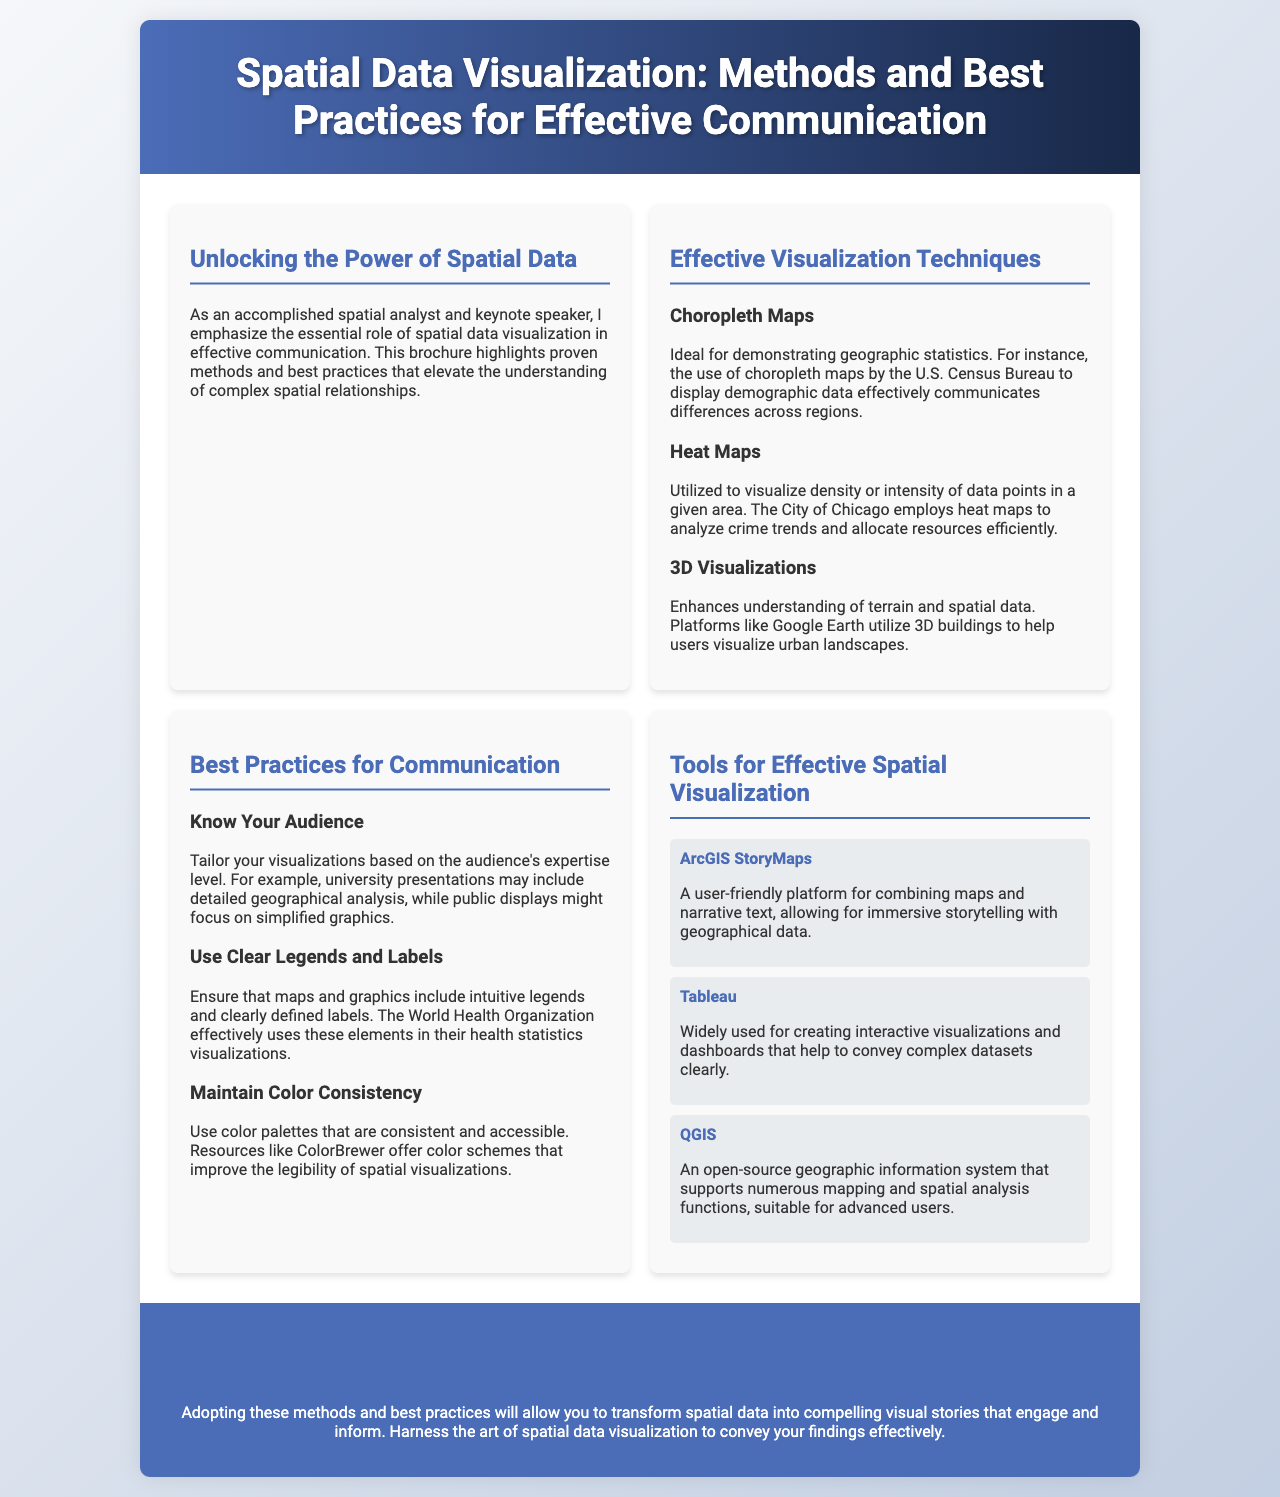what is the title of the brochure? The title of the brochure is prominently displayed in the header section.
Answer: Spatial Data Visualization: Methods and Best Practices for Effective Communication who is the intended audience for the visualization techniques? The document mentions tailoring visualizations based on the audience's expertise level, indicating different target groups.
Answer: Audience's expertise level what is one example of an effective visualization technique mentioned? The brochure lists specific techniques within the Effective Visualization Techniques section.
Answer: Choropleth Maps which tool is described as user-friendly for combining maps and narrative text? The document identifies specific tools for spatial visualization in the Tools section.
Answer: ArcGIS StoryMaps what does the World Health Organization effectively use in their visualizations? The text refers to best practices for communication and gives an example of an organization.
Answer: Clear Legends and Labels how many visualization techniques are highlighted in the document? The document lists a set of different visualization techniques under a specific section.
Answer: Three what is suggested for maintaining color consistency? The document provides guidance on best practices related to color usage in visualizations.
Answer: ColorBrewer what is the conclusion section meant to emphasize? The purpose of the conclusion is stated explicitly at the end of the brochure.
Answer: Transform spatial data into compelling visual stories 